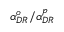<formula> <loc_0><loc_0><loc_500><loc_500>\alpha _ { D R } ^ { o } / \alpha _ { D R } ^ { p }</formula> 